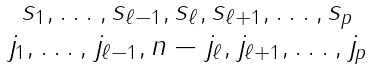<formula> <loc_0><loc_0><loc_500><loc_500>\begin{matrix} s _ { 1 } , \dots , s _ { \ell - 1 } , s _ { \ell } , s _ { \ell + 1 } , \dots , s _ { p } \\ j _ { 1 } , \dots , j _ { \ell - 1 } , n - j _ { \ell } , j _ { \ell + 1 } , \dots , j _ { p } \end{matrix}</formula> 